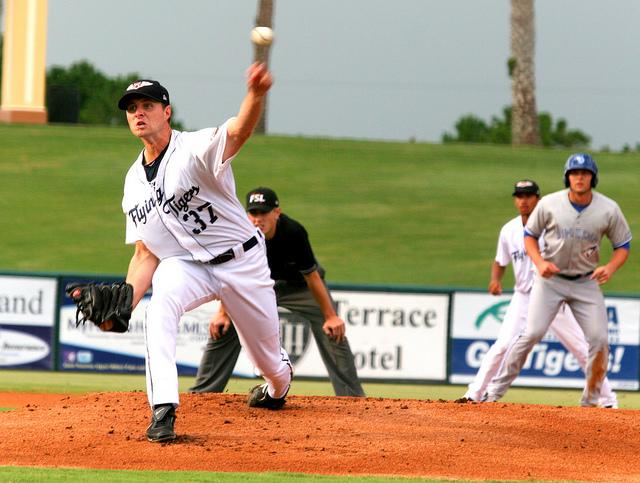Is he throwing a ball?
Short answer required. Yes. What number is on the jersey?
Answer briefly. 37. What color is the pitcher's mitt in this photo?
Give a very brief answer. Black. What hotel chain is advertised in the background?
Be succinct. Terrace hotel. 